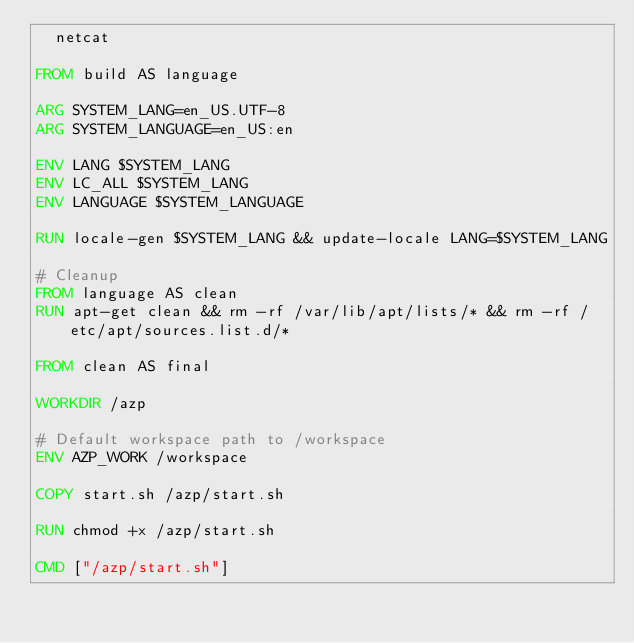Convert code to text. <code><loc_0><loc_0><loc_500><loc_500><_Dockerfile_>  netcat

FROM build AS language

ARG SYSTEM_LANG=en_US.UTF-8
ARG SYSTEM_LANGUAGE=en_US:en

ENV LANG $SYSTEM_LANG
ENV LC_ALL $SYSTEM_LANG
ENV LANGUAGE $SYSTEM_LANGUAGE

RUN locale-gen $SYSTEM_LANG && update-locale LANG=$SYSTEM_LANG

# Cleanup
FROM language AS clean
RUN apt-get clean && rm -rf /var/lib/apt/lists/* && rm -rf /etc/apt/sources.list.d/*

FROM clean AS final

WORKDIR /azp

# Default workspace path to /workspace
ENV AZP_WORK /workspace

COPY start.sh /azp/start.sh

RUN chmod +x /azp/start.sh

CMD ["/azp/start.sh"]
</code> 